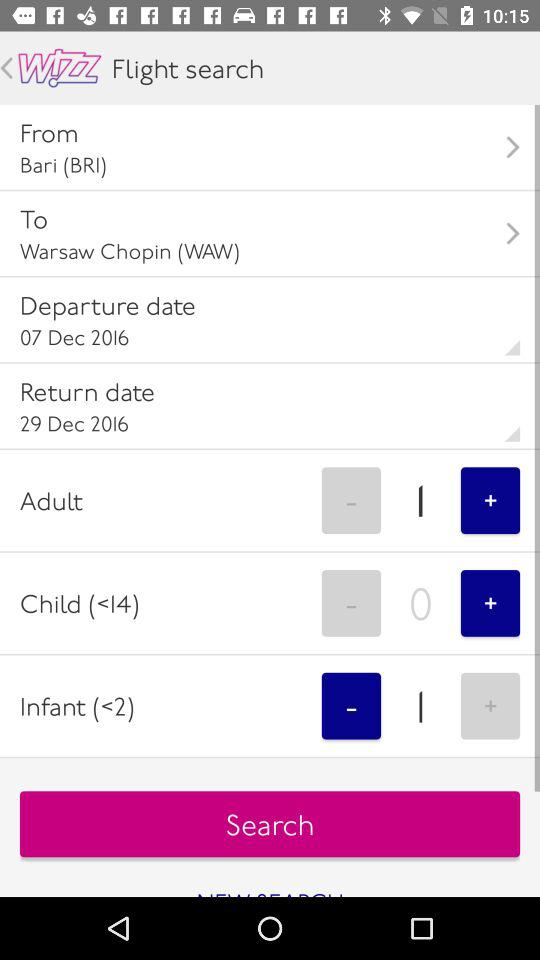How many children are there? There are 0 children. 